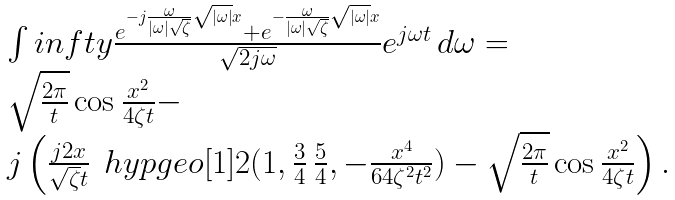Convert formula to latex. <formula><loc_0><loc_0><loc_500><loc_500>\begin{array} { l } \int i n f t y \frac { e ^ { - j \frac { \omega } { | \omega | \sqrt { \zeta } } \sqrt { | \omega | } x } + e ^ { - \frac { \omega } { | \omega | \sqrt { \zeta } } \sqrt { | \omega | } x } } { \sqrt { 2 j \omega } } e ^ { j \omega t } \, d \omega = \\ \sqrt { \frac { 2 \pi } { t } } \cos \frac { x ^ { 2 } } { 4 \zeta t } - \\ j \left ( \frac { j 2 x } { \sqrt { \zeta } t } \, \ h y p g e o [ 1 ] { 2 } ( 1 , \frac { 3 } { 4 } \, \frac { 5 } { 4 } , - \frac { x ^ { 4 } } { 6 4 \zeta ^ { 2 } t ^ { 2 } } ) - \sqrt { \frac { 2 \pi } { t } } \cos \frac { x ^ { 2 } } { 4 \zeta t } \right ) . \end{array}</formula> 